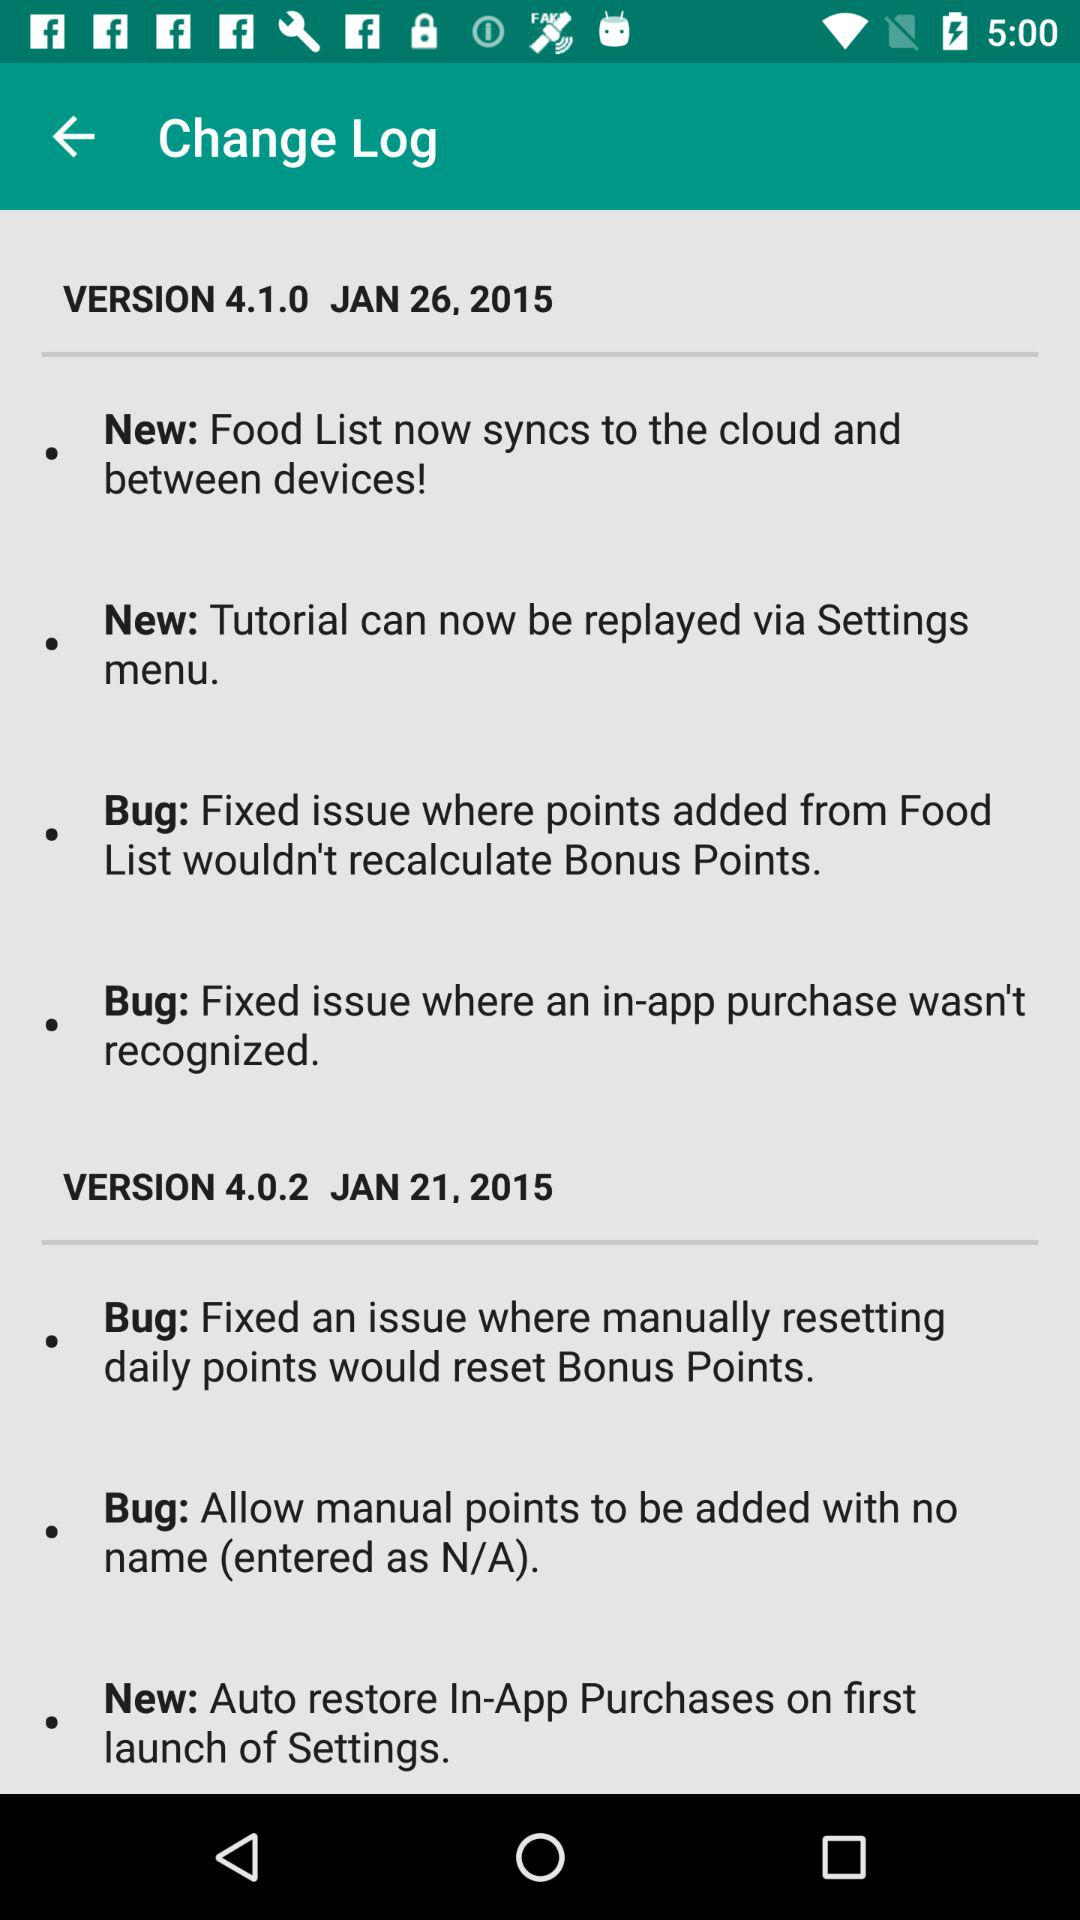On what date was version 4.0.2 updated? It was updated on January 26, 2015. 